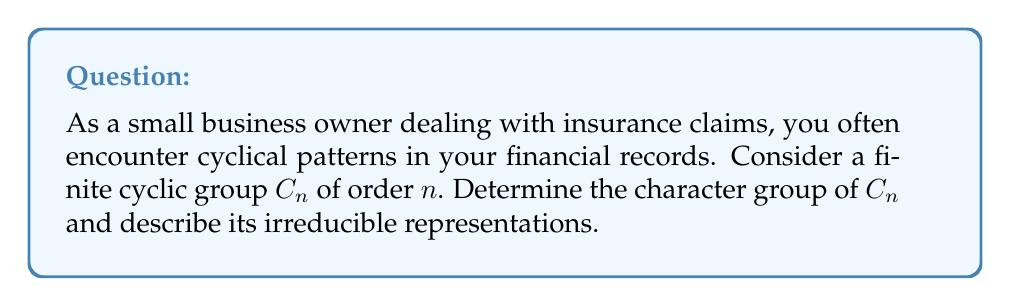Could you help me with this problem? Let's approach this step-by-step:

1) First, recall that a finite cyclic group $C_n$ of order $n$ is isomorphic to the additive group $\mathbb{Z}/n\mathbb{Z}$.

2) The character group of $C_n$, denoted $\widehat{C_n}$, consists of all homomorphisms from $C_n$ to the multiplicative group of complex numbers of unit modulus, $S^1 = \{z \in \mathbb{C} : |z| = 1\}$.

3) For any character $\chi \in \widehat{C_n}$ and generator $g$ of $C_n$, we must have $\chi(g^n) = \chi(e) = 1$, where $e$ is the identity element.

4) This implies that $\chi(g) = e^{2\pi i k/n}$ for some integer $k$, $0 \leq k < n$.

5) Therefore, the characters of $C_n$ are given by:

   $$\chi_k(g^j) = e^{2\pi i k j/n}, \quad k = 0, 1, ..., n-1$$

6) These $n$ distinct characters form a group under multiplication, which is isomorphic to $C_n$ itself.

7) For irreducible representations, note that every character of a cyclic group determines a 1-dimensional representation, and all irreducible representations of abelian groups are 1-dimensional.

8) Therefore, the irreducible representations of $C_n$ are precisely these $n$ 1-dimensional representations given by the characters $\chi_k$.
Answer: $\widehat{C_n} \cong C_n$; $n$ 1-dimensional irreducible representations given by $\chi_k(g^j) = e^{2\pi i k j/n}$, $k = 0, 1, ..., n-1$. 